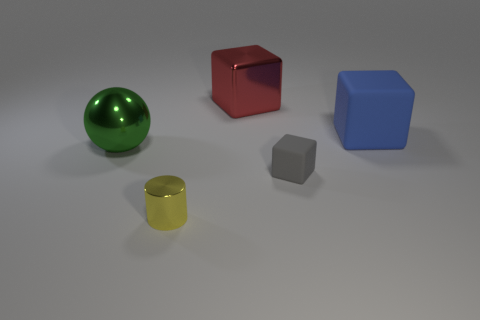There is a big cube that is in front of the big metallic block; is there a thing to the left of it?
Give a very brief answer. Yes. There is a object that is behind the large rubber block; what color is it?
Give a very brief answer. Red. Is the number of blue objects that are behind the blue matte thing the same as the number of shiny cubes?
Ensure brevity in your answer.  No. What shape is the big thing that is both on the left side of the small matte thing and on the right side of the green shiny object?
Offer a terse response. Cube. What is the color of the other tiny thing that is the same shape as the blue matte thing?
Provide a succinct answer. Gray. There is a red shiny object that is behind the rubber cube behind the tiny thing on the right side of the large red cube; what shape is it?
Provide a succinct answer. Cube. Do the shiny object on the left side of the cylinder and the rubber cube in front of the large blue object have the same size?
Keep it short and to the point. No. How many big red blocks are the same material as the large blue block?
Offer a terse response. 0. What number of balls are left of the thing in front of the tiny thing that is behind the yellow cylinder?
Keep it short and to the point. 1. Do the big red thing and the small yellow metal thing have the same shape?
Ensure brevity in your answer.  No. 